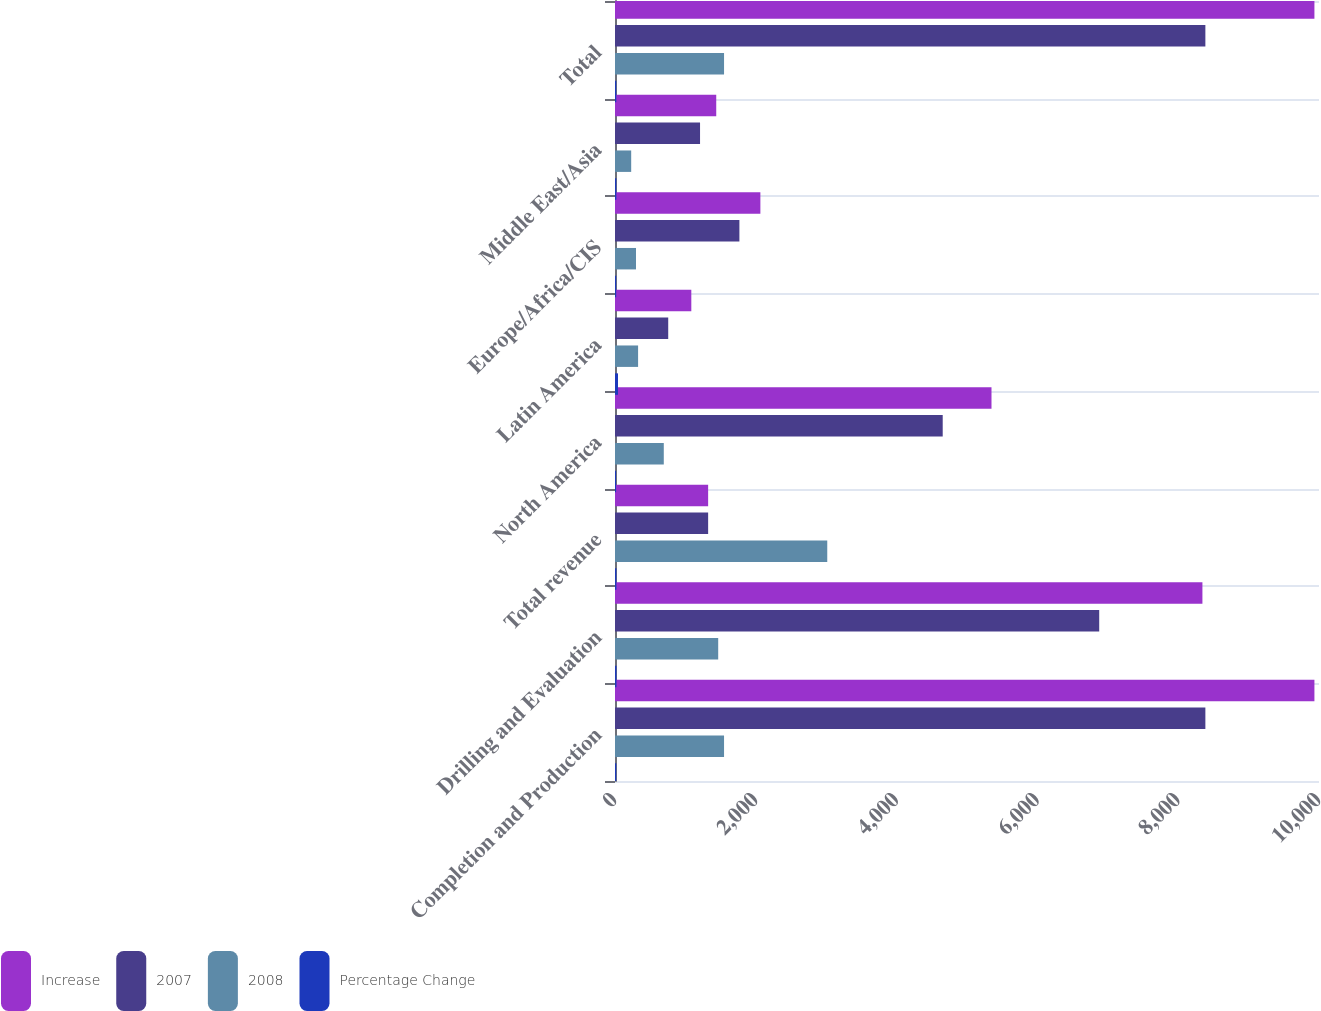Convert chart. <chart><loc_0><loc_0><loc_500><loc_500><stacked_bar_chart><ecel><fcel>Completion and Production<fcel>Drilling and Evaluation<fcel>Total revenue<fcel>North America<fcel>Latin America<fcel>Europe/Africa/CIS<fcel>Middle East/Asia<fcel>Total<nl><fcel>Increase<fcel>9935<fcel>8344<fcel>1323<fcel>5348<fcel>1084<fcel>2065<fcel>1438<fcel>9935<nl><fcel>2007<fcel>8386<fcel>6878<fcel>1323<fcel>4655<fcel>756<fcel>1767<fcel>1208<fcel>8386<nl><fcel>2008<fcel>1549<fcel>1466<fcel>3015<fcel>693<fcel>328<fcel>298<fcel>230<fcel>1549<nl><fcel>Percentage Change<fcel>18<fcel>21<fcel>20<fcel>15<fcel>43<fcel>17<fcel>19<fcel>18<nl></chart> 